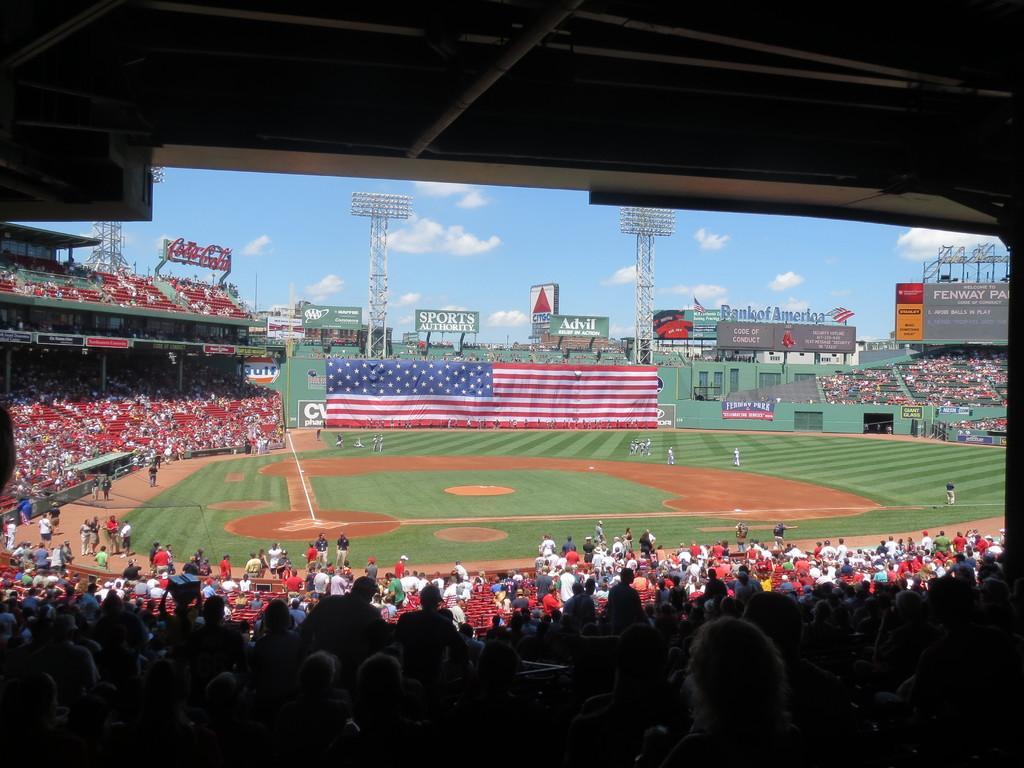Describe this image in one or two sentences. In the picture we can see a stadium with a playground with some parts of the green color mat and on it we can see some people are standing with a sportswear and around the ground we can see audience are sitting in the chairs and in the background, we can see a wall with the United States of America flag and beside it we can see a green color wall with railing and behind it we can see two towers with lights and behind it we can see the sky with clouds. 